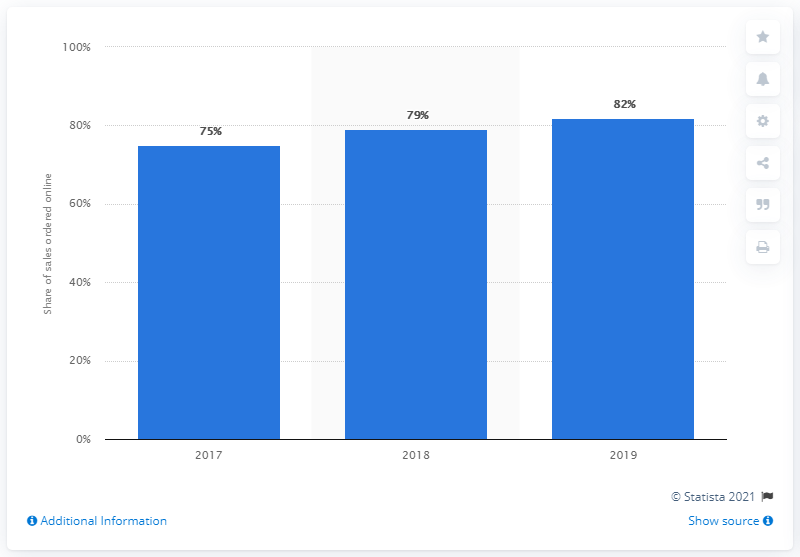List a handful of essential elements in this visual. The highest share of shares with the 2019 date can be found in the year 2019. In 2019, 82% of Domino's Pizza's sales were generated through online ordering. The median is 79. 